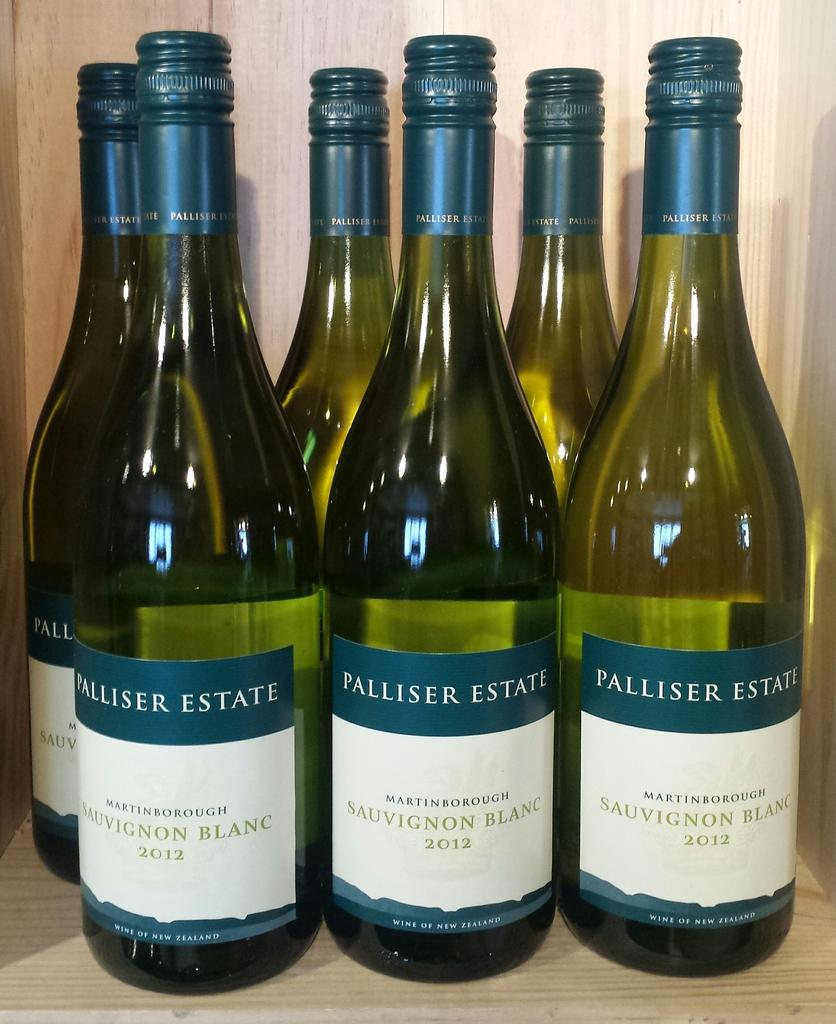<image>
Write a terse but informative summary of the picture. A group of six wine bottles from Palliser Estate. 